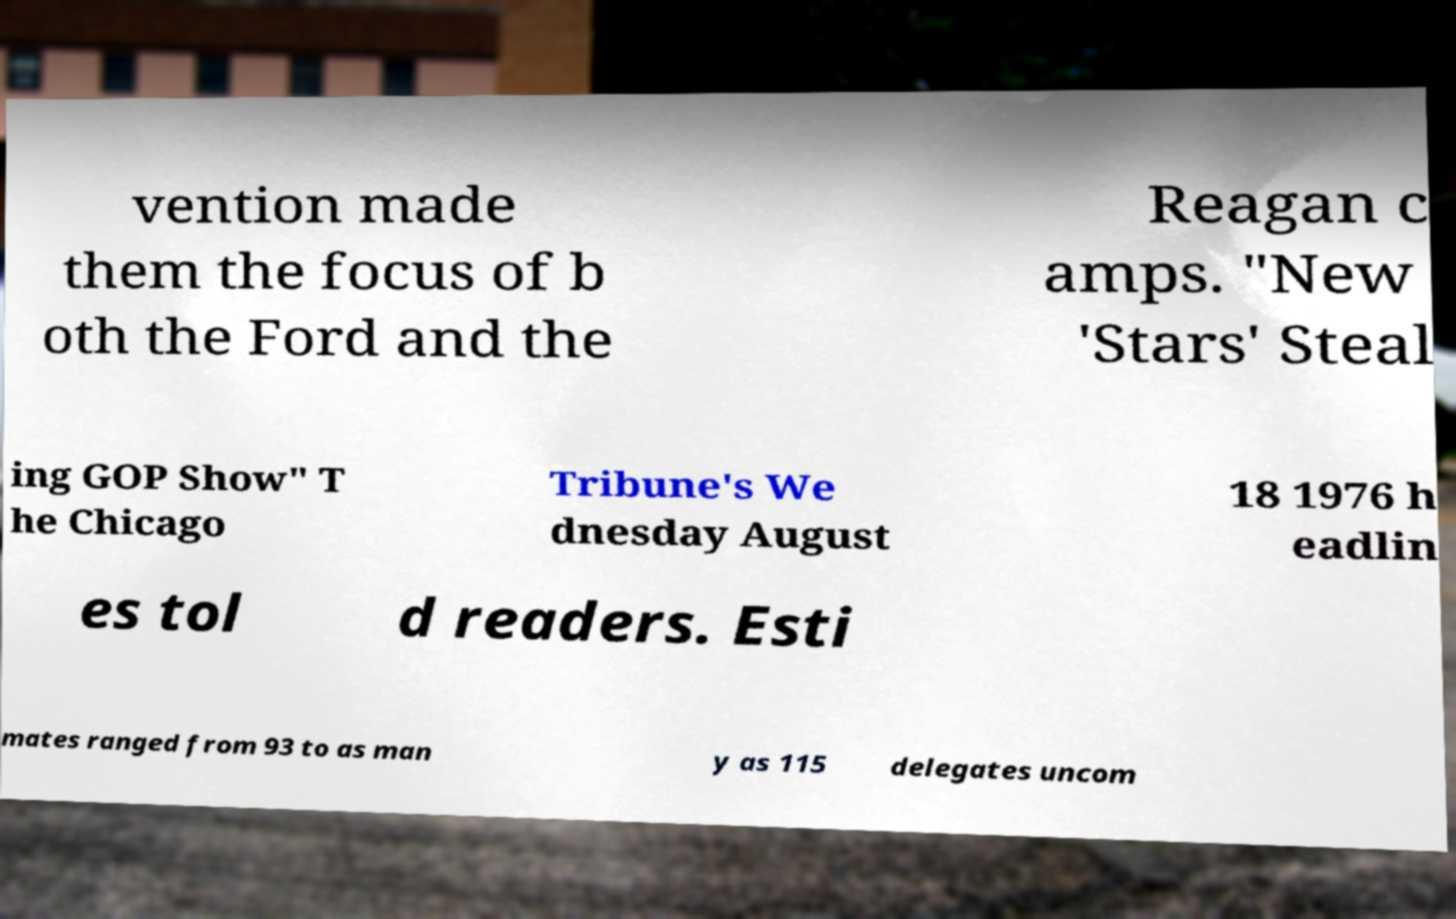Please read and relay the text visible in this image. What does it say? vention made them the focus of b oth the Ford and the Reagan c amps. "New 'Stars' Steal ing GOP Show" T he Chicago Tribune's We dnesday August 18 1976 h eadlin es tol d readers. Esti mates ranged from 93 to as man y as 115 delegates uncom 